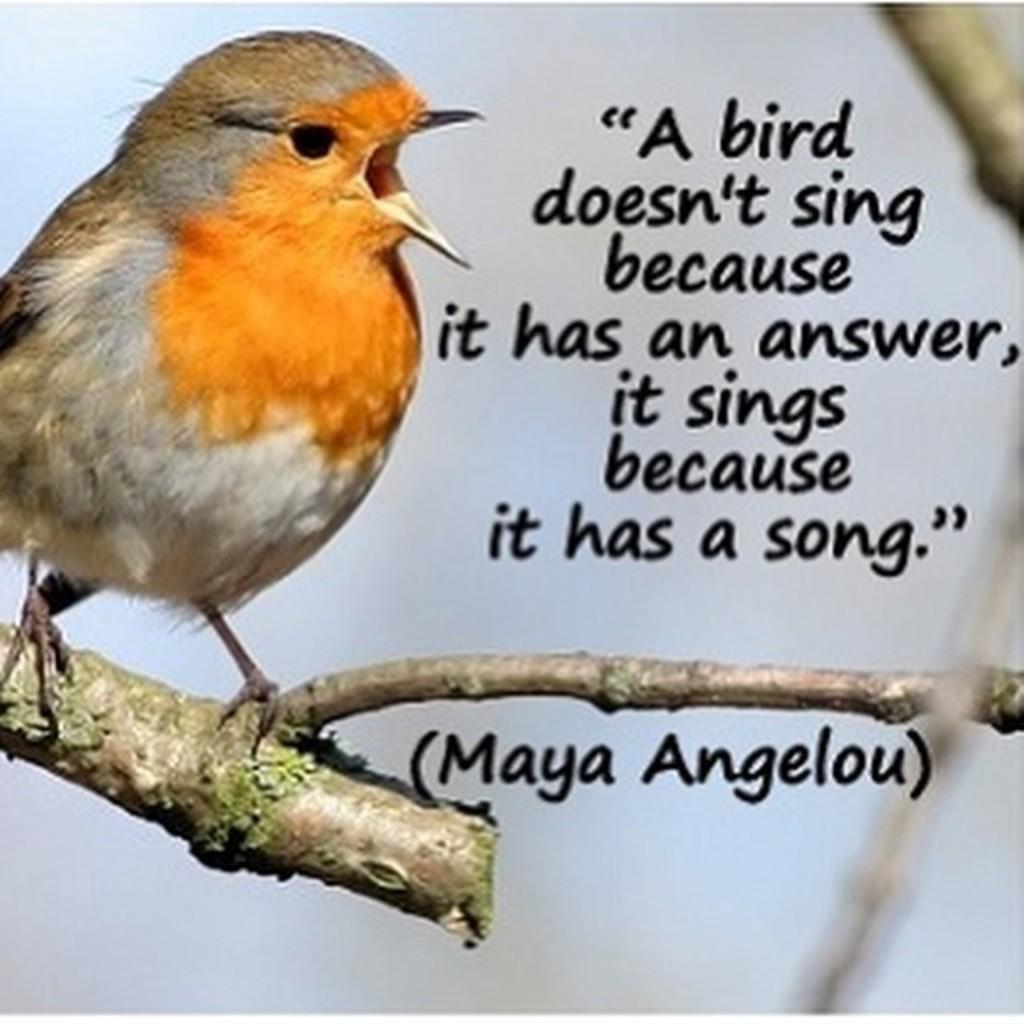What type of animal can be seen in the image? There is a bird in the image. Where is the bird located? The bird is standing on a branch of a tree. What else is present in the image besides the bird? There is text in the image. What can be seen in the background of the image? The sky is visible in the background of the image, along with other objects. How many kittens are sitting on the queen's lap in the image? There are no kittens or queens present in the image; it features a bird on a tree branch. 